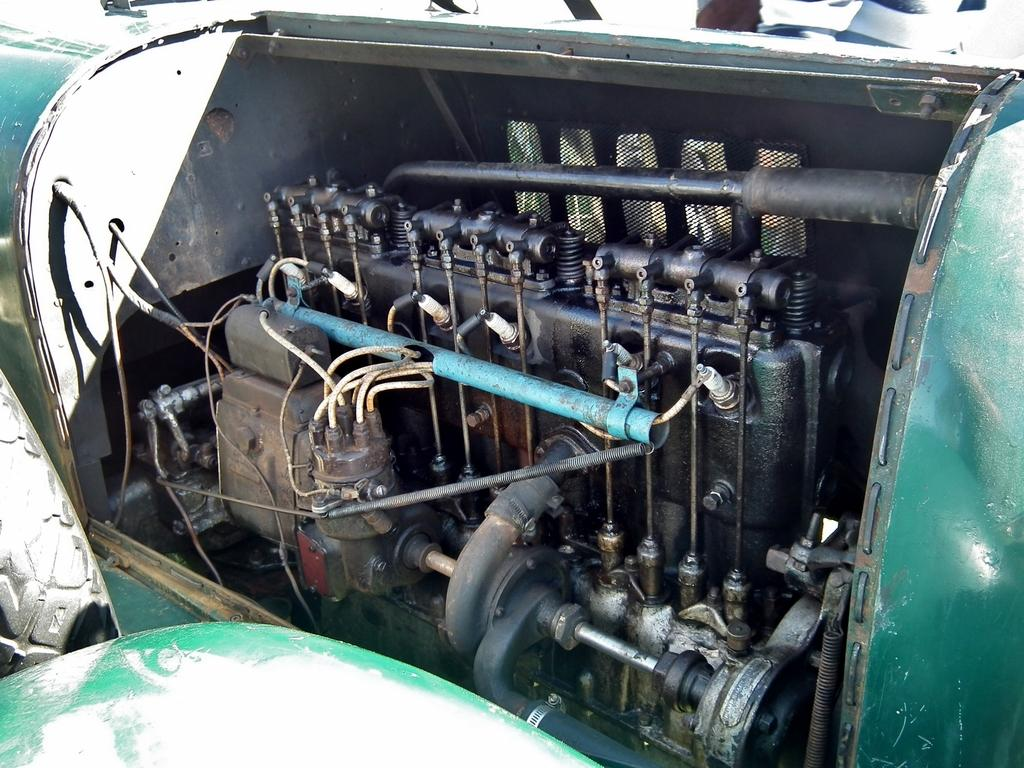What part of a vehicle is the main subject of the image? The main subject of the image is the engine of a vehicle. Can you describe another part of the vehicle that is visible in the image? Yes, there is a wheel of the vehicle on the left side of the image. What color is the background of the image? The background of the image is green in color. How many songs can be heard playing from the cactus in the image? There is no cactus present in the image, and therefore no songs can be heard playing from it. 